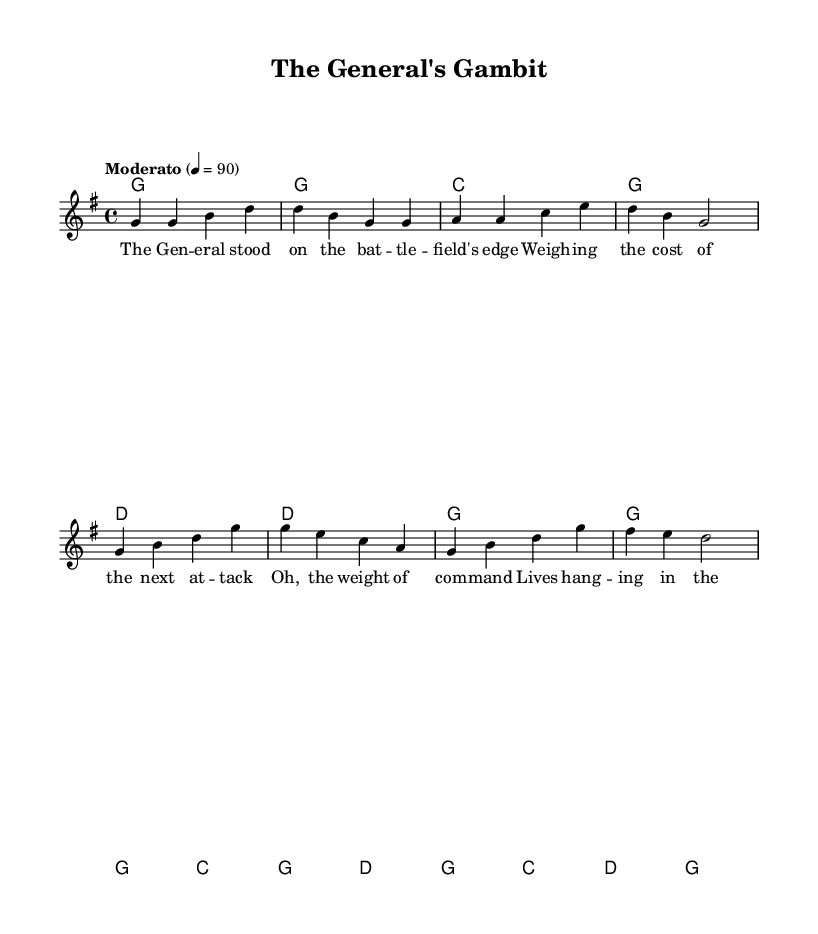What is the key signature of this music? The key signature is G major, which has one sharp (F#). This can be determined by looking at the beginning of the score, where the key is notated.
Answer: G major What is the time signature of this music? The time signature is 4/4, indicated at the beginning of the score after the key signature. It means there are four beats per measure and a quarter note gets one beat.
Answer: 4/4 What is the tempo marking of this piece? The tempo marking is "Moderato," which indicates a moderate speed of the piece. It also specifies the metronome marking of 90 beats per minute, listed right below the tempo indication.
Answer: Moderato What do the chord symbols represent for the verse? The chord symbols for the verse are G, C, and D, which indicate the harmonic structure that accompanies the melody. These chords are placed above the melody line and suggest the foundational harmony of the song.
Answer: G, C, D How does the chorus differ from the verse in terms of chords? The chorus includes chords G, C, and D, similar to the verse, but arranged differently. The sequence indicates a shift in musical emphasis and often provides a contrasting emotional expression in country music.
Answer: Similarity in chords, different arrangement What thematic element is present in the lyrics of this piece? The lyrics reflect the theme of strategic decision-making during wartime, as indicated by references to weighing costs and the weight of command, which resonates with the historical context of military action.
Answer: Strategic decision-making Which part of the song carries the emotional climax? The chorus typically carries the emotional climax; in this score, it features the shift in lyrics and the emphasis placed on harmony and melody, which heightens the emotional response of the listener.
Answer: Chorus 